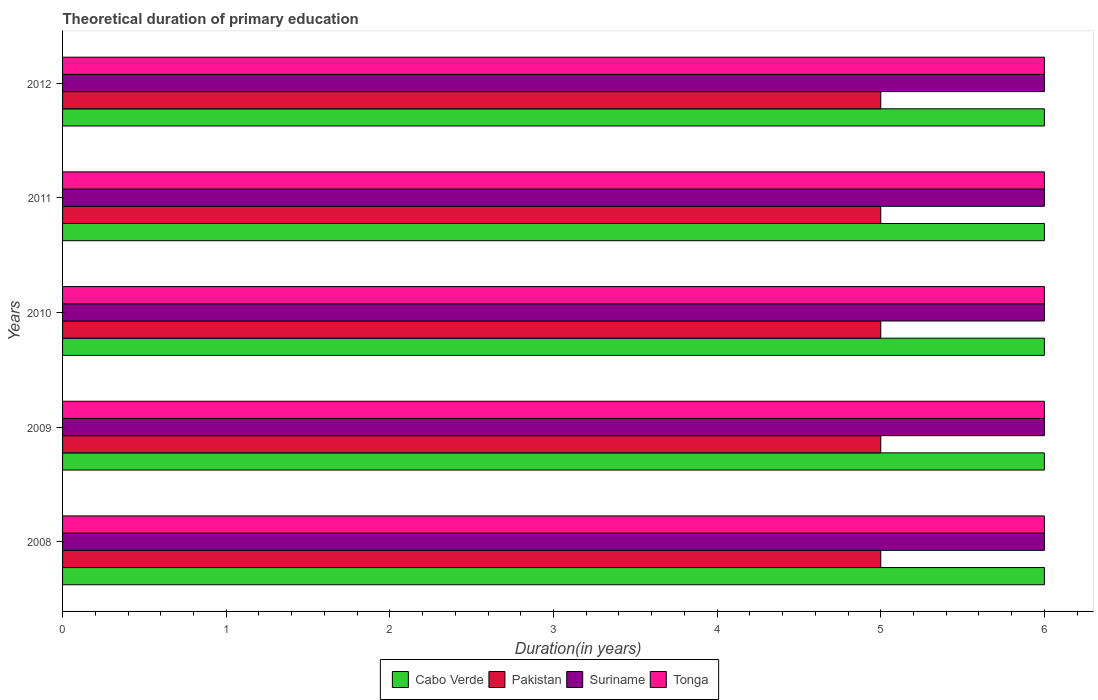Are the number of bars on each tick of the Y-axis equal?
Provide a short and direct response. Yes. How many bars are there on the 5th tick from the bottom?
Offer a terse response. 4. In how many cases, is the number of bars for a given year not equal to the number of legend labels?
Ensure brevity in your answer.  0. What is the total theoretical duration of primary education in Cabo Verde in 2011?
Offer a very short reply. 6. Across all years, what is the maximum total theoretical duration of primary education in Tonga?
Provide a succinct answer. 6. Across all years, what is the minimum total theoretical duration of primary education in Cabo Verde?
Your answer should be very brief. 6. In which year was the total theoretical duration of primary education in Pakistan maximum?
Your answer should be very brief. 2008. What is the total total theoretical duration of primary education in Cabo Verde in the graph?
Offer a very short reply. 30. What is the difference between the total theoretical duration of primary education in Pakistan in 2008 and that in 2012?
Give a very brief answer. 0. What is the difference between the total theoretical duration of primary education in Pakistan in 2010 and the total theoretical duration of primary education in Tonga in 2009?
Offer a terse response. -1. What is the average total theoretical duration of primary education in Suriname per year?
Give a very brief answer. 6. In the year 2008, what is the difference between the total theoretical duration of primary education in Pakistan and total theoretical duration of primary education in Suriname?
Provide a short and direct response. -1. In how many years, is the total theoretical duration of primary education in Tonga greater than 3.8 years?
Make the answer very short. 5. What is the ratio of the total theoretical duration of primary education in Cabo Verde in 2010 to that in 2012?
Your response must be concise. 1. Is the difference between the total theoretical duration of primary education in Pakistan in 2011 and 2012 greater than the difference between the total theoretical duration of primary education in Suriname in 2011 and 2012?
Your answer should be very brief. No. What is the difference between the highest and the lowest total theoretical duration of primary education in Suriname?
Your answer should be compact. 0. Is the sum of the total theoretical duration of primary education in Tonga in 2008 and 2010 greater than the maximum total theoretical duration of primary education in Pakistan across all years?
Your answer should be very brief. Yes. What does the 4th bar from the top in 2009 represents?
Offer a terse response. Cabo Verde. What does the 3rd bar from the bottom in 2008 represents?
Offer a terse response. Suriname. Is it the case that in every year, the sum of the total theoretical duration of primary education in Tonga and total theoretical duration of primary education in Cabo Verde is greater than the total theoretical duration of primary education in Suriname?
Make the answer very short. Yes. How many bars are there?
Your answer should be compact. 20. What is the difference between two consecutive major ticks on the X-axis?
Your answer should be very brief. 1. Does the graph contain any zero values?
Provide a succinct answer. No. What is the title of the graph?
Give a very brief answer. Theoretical duration of primary education. Does "Tajikistan" appear as one of the legend labels in the graph?
Ensure brevity in your answer.  No. What is the label or title of the X-axis?
Make the answer very short. Duration(in years). What is the Duration(in years) of Cabo Verde in 2008?
Your answer should be very brief. 6. What is the Duration(in years) of Pakistan in 2008?
Ensure brevity in your answer.  5. What is the Duration(in years) in Tonga in 2008?
Offer a very short reply. 6. What is the Duration(in years) in Pakistan in 2009?
Your answer should be very brief. 5. What is the Duration(in years) in Suriname in 2009?
Provide a short and direct response. 6. What is the Duration(in years) in Tonga in 2009?
Offer a very short reply. 6. What is the Duration(in years) of Pakistan in 2010?
Ensure brevity in your answer.  5. What is the Duration(in years) in Cabo Verde in 2011?
Your answer should be very brief. 6. What is the Duration(in years) of Tonga in 2011?
Ensure brevity in your answer.  6. What is the Duration(in years) of Suriname in 2012?
Give a very brief answer. 6. What is the Duration(in years) in Tonga in 2012?
Provide a succinct answer. 6. Across all years, what is the maximum Duration(in years) in Cabo Verde?
Provide a short and direct response. 6. Across all years, what is the maximum Duration(in years) of Pakistan?
Offer a very short reply. 5. Across all years, what is the maximum Duration(in years) of Suriname?
Offer a terse response. 6. Across all years, what is the maximum Duration(in years) of Tonga?
Offer a very short reply. 6. Across all years, what is the minimum Duration(in years) of Cabo Verde?
Your response must be concise. 6. Across all years, what is the minimum Duration(in years) of Suriname?
Provide a succinct answer. 6. Across all years, what is the minimum Duration(in years) in Tonga?
Offer a very short reply. 6. What is the total Duration(in years) in Cabo Verde in the graph?
Keep it short and to the point. 30. What is the total Duration(in years) of Pakistan in the graph?
Offer a terse response. 25. What is the total Duration(in years) in Tonga in the graph?
Provide a short and direct response. 30. What is the difference between the Duration(in years) of Cabo Verde in 2008 and that in 2009?
Offer a very short reply. 0. What is the difference between the Duration(in years) of Cabo Verde in 2008 and that in 2010?
Your response must be concise. 0. What is the difference between the Duration(in years) of Pakistan in 2008 and that in 2010?
Provide a short and direct response. 0. What is the difference between the Duration(in years) of Suriname in 2008 and that in 2011?
Your response must be concise. 0. What is the difference between the Duration(in years) of Cabo Verde in 2008 and that in 2012?
Give a very brief answer. 0. What is the difference between the Duration(in years) of Tonga in 2008 and that in 2012?
Ensure brevity in your answer.  0. What is the difference between the Duration(in years) in Cabo Verde in 2009 and that in 2010?
Your answer should be very brief. 0. What is the difference between the Duration(in years) in Suriname in 2009 and that in 2010?
Your response must be concise. 0. What is the difference between the Duration(in years) of Pakistan in 2009 and that in 2011?
Ensure brevity in your answer.  0. What is the difference between the Duration(in years) of Pakistan in 2009 and that in 2012?
Your response must be concise. 0. What is the difference between the Duration(in years) in Suriname in 2009 and that in 2012?
Your response must be concise. 0. What is the difference between the Duration(in years) of Tonga in 2009 and that in 2012?
Your answer should be compact. 0. What is the difference between the Duration(in years) in Suriname in 2010 and that in 2011?
Your answer should be compact. 0. What is the difference between the Duration(in years) in Tonga in 2010 and that in 2011?
Give a very brief answer. 0. What is the difference between the Duration(in years) in Suriname in 2010 and that in 2012?
Your answer should be very brief. 0. What is the difference between the Duration(in years) of Cabo Verde in 2011 and that in 2012?
Make the answer very short. 0. What is the difference between the Duration(in years) of Pakistan in 2011 and that in 2012?
Make the answer very short. 0. What is the difference between the Duration(in years) of Suriname in 2011 and that in 2012?
Your answer should be very brief. 0. What is the difference between the Duration(in years) in Tonga in 2011 and that in 2012?
Offer a terse response. 0. What is the difference between the Duration(in years) of Cabo Verde in 2008 and the Duration(in years) of Pakistan in 2009?
Offer a terse response. 1. What is the difference between the Duration(in years) of Pakistan in 2008 and the Duration(in years) of Suriname in 2009?
Provide a succinct answer. -1. What is the difference between the Duration(in years) in Cabo Verde in 2008 and the Duration(in years) in Pakistan in 2010?
Your answer should be very brief. 1. What is the difference between the Duration(in years) in Cabo Verde in 2008 and the Duration(in years) in Suriname in 2010?
Provide a succinct answer. 0. What is the difference between the Duration(in years) of Cabo Verde in 2008 and the Duration(in years) of Tonga in 2010?
Provide a succinct answer. 0. What is the difference between the Duration(in years) of Pakistan in 2008 and the Duration(in years) of Suriname in 2010?
Your answer should be very brief. -1. What is the difference between the Duration(in years) of Suriname in 2008 and the Duration(in years) of Tonga in 2010?
Give a very brief answer. 0. What is the difference between the Duration(in years) of Pakistan in 2008 and the Duration(in years) of Suriname in 2011?
Your response must be concise. -1. What is the difference between the Duration(in years) in Suriname in 2008 and the Duration(in years) in Tonga in 2012?
Offer a terse response. 0. What is the difference between the Duration(in years) in Pakistan in 2009 and the Duration(in years) in Suriname in 2010?
Offer a terse response. -1. What is the difference between the Duration(in years) of Pakistan in 2009 and the Duration(in years) of Tonga in 2010?
Your answer should be compact. -1. What is the difference between the Duration(in years) in Suriname in 2009 and the Duration(in years) in Tonga in 2010?
Your answer should be very brief. 0. What is the difference between the Duration(in years) in Cabo Verde in 2009 and the Duration(in years) in Pakistan in 2011?
Your answer should be compact. 1. What is the difference between the Duration(in years) in Cabo Verde in 2009 and the Duration(in years) in Suriname in 2011?
Ensure brevity in your answer.  0. What is the difference between the Duration(in years) in Cabo Verde in 2009 and the Duration(in years) in Tonga in 2011?
Your answer should be very brief. 0. What is the difference between the Duration(in years) in Pakistan in 2009 and the Duration(in years) in Tonga in 2011?
Offer a very short reply. -1. What is the difference between the Duration(in years) of Suriname in 2009 and the Duration(in years) of Tonga in 2011?
Keep it short and to the point. 0. What is the difference between the Duration(in years) in Cabo Verde in 2009 and the Duration(in years) in Pakistan in 2012?
Your answer should be very brief. 1. What is the difference between the Duration(in years) in Cabo Verde in 2009 and the Duration(in years) in Tonga in 2012?
Give a very brief answer. 0. What is the difference between the Duration(in years) of Pakistan in 2009 and the Duration(in years) of Suriname in 2012?
Your answer should be very brief. -1. What is the difference between the Duration(in years) of Pakistan in 2009 and the Duration(in years) of Tonga in 2012?
Keep it short and to the point. -1. What is the difference between the Duration(in years) in Suriname in 2009 and the Duration(in years) in Tonga in 2012?
Offer a very short reply. 0. What is the difference between the Duration(in years) of Cabo Verde in 2010 and the Duration(in years) of Suriname in 2011?
Provide a succinct answer. 0. What is the difference between the Duration(in years) of Cabo Verde in 2010 and the Duration(in years) of Tonga in 2011?
Your answer should be compact. 0. What is the difference between the Duration(in years) in Cabo Verde in 2010 and the Duration(in years) in Tonga in 2012?
Ensure brevity in your answer.  0. What is the difference between the Duration(in years) of Pakistan in 2010 and the Duration(in years) of Tonga in 2012?
Keep it short and to the point. -1. What is the difference between the Duration(in years) of Pakistan in 2011 and the Duration(in years) of Suriname in 2012?
Your answer should be very brief. -1. What is the difference between the Duration(in years) in Suriname in 2011 and the Duration(in years) in Tonga in 2012?
Your answer should be compact. 0. What is the average Duration(in years) of Cabo Verde per year?
Give a very brief answer. 6. What is the average Duration(in years) of Pakistan per year?
Offer a very short reply. 5. In the year 2008, what is the difference between the Duration(in years) of Cabo Verde and Duration(in years) of Pakistan?
Provide a succinct answer. 1. In the year 2008, what is the difference between the Duration(in years) in Cabo Verde and Duration(in years) in Suriname?
Provide a succinct answer. 0. In the year 2008, what is the difference between the Duration(in years) of Cabo Verde and Duration(in years) of Tonga?
Offer a terse response. 0. In the year 2008, what is the difference between the Duration(in years) of Pakistan and Duration(in years) of Suriname?
Your response must be concise. -1. In the year 2009, what is the difference between the Duration(in years) of Pakistan and Duration(in years) of Suriname?
Give a very brief answer. -1. In the year 2009, what is the difference between the Duration(in years) in Suriname and Duration(in years) in Tonga?
Provide a short and direct response. 0. In the year 2010, what is the difference between the Duration(in years) of Cabo Verde and Duration(in years) of Pakistan?
Your answer should be very brief. 1. In the year 2010, what is the difference between the Duration(in years) in Suriname and Duration(in years) in Tonga?
Offer a terse response. 0. In the year 2011, what is the difference between the Duration(in years) in Cabo Verde and Duration(in years) in Pakistan?
Keep it short and to the point. 1. In the year 2011, what is the difference between the Duration(in years) of Pakistan and Duration(in years) of Tonga?
Ensure brevity in your answer.  -1. In the year 2012, what is the difference between the Duration(in years) of Cabo Verde and Duration(in years) of Pakistan?
Offer a terse response. 1. In the year 2012, what is the difference between the Duration(in years) of Cabo Verde and Duration(in years) of Suriname?
Offer a terse response. 0. What is the ratio of the Duration(in years) in Cabo Verde in 2008 to that in 2009?
Your answer should be very brief. 1. What is the ratio of the Duration(in years) in Pakistan in 2008 to that in 2009?
Offer a very short reply. 1. What is the ratio of the Duration(in years) in Suriname in 2008 to that in 2009?
Your answer should be very brief. 1. What is the ratio of the Duration(in years) of Tonga in 2008 to that in 2009?
Make the answer very short. 1. What is the ratio of the Duration(in years) of Cabo Verde in 2008 to that in 2010?
Offer a very short reply. 1. What is the ratio of the Duration(in years) in Pakistan in 2008 to that in 2011?
Offer a very short reply. 1. What is the ratio of the Duration(in years) of Pakistan in 2008 to that in 2012?
Make the answer very short. 1. What is the ratio of the Duration(in years) of Suriname in 2008 to that in 2012?
Provide a succinct answer. 1. What is the ratio of the Duration(in years) of Tonga in 2008 to that in 2012?
Your answer should be compact. 1. What is the ratio of the Duration(in years) of Cabo Verde in 2009 to that in 2010?
Make the answer very short. 1. What is the ratio of the Duration(in years) of Pakistan in 2009 to that in 2010?
Provide a short and direct response. 1. What is the ratio of the Duration(in years) in Suriname in 2009 to that in 2010?
Your answer should be compact. 1. What is the ratio of the Duration(in years) of Tonga in 2009 to that in 2010?
Provide a succinct answer. 1. What is the ratio of the Duration(in years) of Cabo Verde in 2009 to that in 2011?
Keep it short and to the point. 1. What is the ratio of the Duration(in years) of Suriname in 2009 to that in 2011?
Offer a very short reply. 1. What is the ratio of the Duration(in years) of Tonga in 2009 to that in 2011?
Provide a short and direct response. 1. What is the ratio of the Duration(in years) in Suriname in 2009 to that in 2012?
Your response must be concise. 1. What is the ratio of the Duration(in years) of Cabo Verde in 2010 to that in 2011?
Ensure brevity in your answer.  1. What is the ratio of the Duration(in years) of Pakistan in 2010 to that in 2012?
Make the answer very short. 1. What is the ratio of the Duration(in years) of Tonga in 2010 to that in 2012?
Provide a succinct answer. 1. What is the ratio of the Duration(in years) in Pakistan in 2011 to that in 2012?
Your answer should be compact. 1. What is the ratio of the Duration(in years) in Suriname in 2011 to that in 2012?
Keep it short and to the point. 1. What is the ratio of the Duration(in years) in Tonga in 2011 to that in 2012?
Keep it short and to the point. 1. What is the difference between the highest and the second highest Duration(in years) in Cabo Verde?
Your answer should be compact. 0. What is the difference between the highest and the second highest Duration(in years) of Pakistan?
Provide a succinct answer. 0. What is the difference between the highest and the second highest Duration(in years) of Suriname?
Provide a short and direct response. 0. What is the difference between the highest and the second highest Duration(in years) of Tonga?
Provide a short and direct response. 0. What is the difference between the highest and the lowest Duration(in years) in Pakistan?
Make the answer very short. 0. 